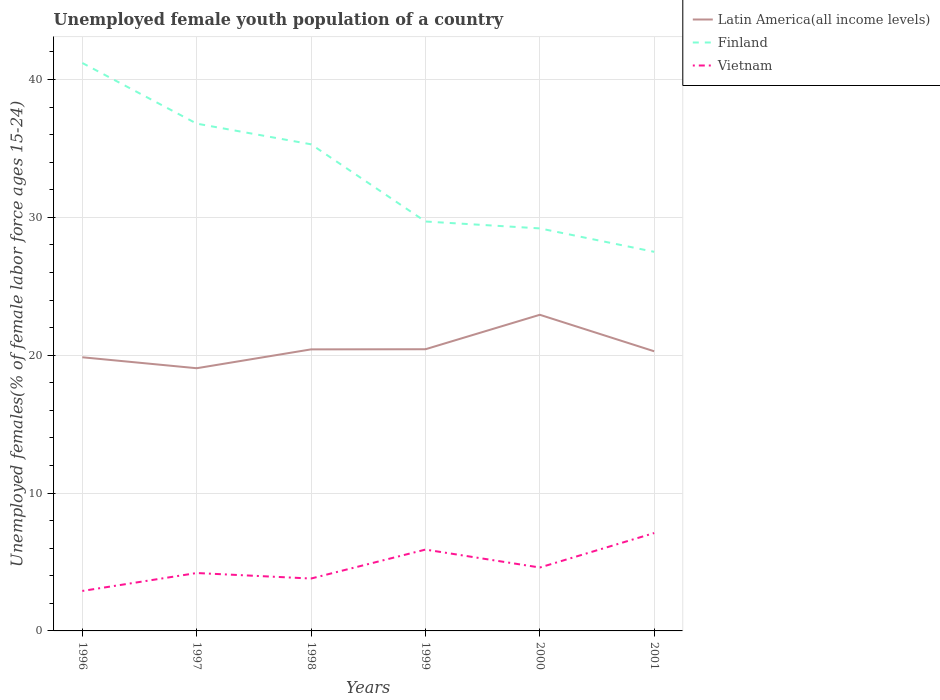How many different coloured lines are there?
Keep it short and to the point. 3. Across all years, what is the maximum percentage of unemployed female youth population in Finland?
Your answer should be very brief. 27.5. In which year was the percentage of unemployed female youth population in Latin America(all income levels) maximum?
Make the answer very short. 1997. What is the total percentage of unemployed female youth population in Vietnam in the graph?
Give a very brief answer. -1.2. What is the difference between the highest and the second highest percentage of unemployed female youth population in Finland?
Keep it short and to the point. 13.7. What is the difference between the highest and the lowest percentage of unemployed female youth population in Vietnam?
Your answer should be very brief. 2. How many years are there in the graph?
Offer a very short reply. 6. How are the legend labels stacked?
Give a very brief answer. Vertical. What is the title of the graph?
Ensure brevity in your answer.  Unemployed female youth population of a country. What is the label or title of the Y-axis?
Provide a short and direct response. Unemployed females(% of female labor force ages 15-24). What is the Unemployed females(% of female labor force ages 15-24) of Latin America(all income levels) in 1996?
Make the answer very short. 19.85. What is the Unemployed females(% of female labor force ages 15-24) of Finland in 1996?
Ensure brevity in your answer.  41.2. What is the Unemployed females(% of female labor force ages 15-24) of Vietnam in 1996?
Offer a very short reply. 2.9. What is the Unemployed females(% of female labor force ages 15-24) of Latin America(all income levels) in 1997?
Your answer should be very brief. 19.06. What is the Unemployed females(% of female labor force ages 15-24) in Finland in 1997?
Give a very brief answer. 36.8. What is the Unemployed females(% of female labor force ages 15-24) of Vietnam in 1997?
Provide a short and direct response. 4.2. What is the Unemployed females(% of female labor force ages 15-24) in Latin America(all income levels) in 1998?
Your answer should be very brief. 20.42. What is the Unemployed females(% of female labor force ages 15-24) of Finland in 1998?
Your answer should be very brief. 35.3. What is the Unemployed females(% of female labor force ages 15-24) of Vietnam in 1998?
Your response must be concise. 3.8. What is the Unemployed females(% of female labor force ages 15-24) of Latin America(all income levels) in 1999?
Offer a terse response. 20.43. What is the Unemployed females(% of female labor force ages 15-24) of Finland in 1999?
Provide a short and direct response. 29.7. What is the Unemployed females(% of female labor force ages 15-24) in Vietnam in 1999?
Provide a short and direct response. 5.9. What is the Unemployed females(% of female labor force ages 15-24) in Latin America(all income levels) in 2000?
Your response must be concise. 22.93. What is the Unemployed females(% of female labor force ages 15-24) of Finland in 2000?
Make the answer very short. 29.2. What is the Unemployed females(% of female labor force ages 15-24) in Vietnam in 2000?
Offer a very short reply. 4.6. What is the Unemployed females(% of female labor force ages 15-24) in Latin America(all income levels) in 2001?
Provide a short and direct response. 20.29. What is the Unemployed females(% of female labor force ages 15-24) in Finland in 2001?
Provide a succinct answer. 27.5. What is the Unemployed females(% of female labor force ages 15-24) in Vietnam in 2001?
Make the answer very short. 7.1. Across all years, what is the maximum Unemployed females(% of female labor force ages 15-24) in Latin America(all income levels)?
Your answer should be compact. 22.93. Across all years, what is the maximum Unemployed females(% of female labor force ages 15-24) of Finland?
Offer a very short reply. 41.2. Across all years, what is the maximum Unemployed females(% of female labor force ages 15-24) of Vietnam?
Your answer should be compact. 7.1. Across all years, what is the minimum Unemployed females(% of female labor force ages 15-24) of Latin America(all income levels)?
Make the answer very short. 19.06. Across all years, what is the minimum Unemployed females(% of female labor force ages 15-24) of Finland?
Keep it short and to the point. 27.5. Across all years, what is the minimum Unemployed females(% of female labor force ages 15-24) in Vietnam?
Your answer should be very brief. 2.9. What is the total Unemployed females(% of female labor force ages 15-24) of Latin America(all income levels) in the graph?
Your answer should be compact. 122.98. What is the total Unemployed females(% of female labor force ages 15-24) of Finland in the graph?
Give a very brief answer. 199.7. What is the difference between the Unemployed females(% of female labor force ages 15-24) of Latin America(all income levels) in 1996 and that in 1997?
Your response must be concise. 0.79. What is the difference between the Unemployed females(% of female labor force ages 15-24) of Finland in 1996 and that in 1997?
Offer a very short reply. 4.4. What is the difference between the Unemployed females(% of female labor force ages 15-24) of Vietnam in 1996 and that in 1997?
Provide a short and direct response. -1.3. What is the difference between the Unemployed females(% of female labor force ages 15-24) in Latin America(all income levels) in 1996 and that in 1998?
Your response must be concise. -0.57. What is the difference between the Unemployed females(% of female labor force ages 15-24) in Vietnam in 1996 and that in 1998?
Offer a very short reply. -0.9. What is the difference between the Unemployed females(% of female labor force ages 15-24) of Latin America(all income levels) in 1996 and that in 1999?
Your answer should be very brief. -0.58. What is the difference between the Unemployed females(% of female labor force ages 15-24) of Latin America(all income levels) in 1996 and that in 2000?
Make the answer very short. -3.08. What is the difference between the Unemployed females(% of female labor force ages 15-24) in Latin America(all income levels) in 1996 and that in 2001?
Make the answer very short. -0.44. What is the difference between the Unemployed females(% of female labor force ages 15-24) in Vietnam in 1996 and that in 2001?
Offer a terse response. -4.2. What is the difference between the Unemployed females(% of female labor force ages 15-24) of Latin America(all income levels) in 1997 and that in 1998?
Your response must be concise. -1.37. What is the difference between the Unemployed females(% of female labor force ages 15-24) of Finland in 1997 and that in 1998?
Provide a short and direct response. 1.5. What is the difference between the Unemployed females(% of female labor force ages 15-24) of Latin America(all income levels) in 1997 and that in 1999?
Provide a succinct answer. -1.38. What is the difference between the Unemployed females(% of female labor force ages 15-24) in Finland in 1997 and that in 1999?
Offer a terse response. 7.1. What is the difference between the Unemployed females(% of female labor force ages 15-24) of Latin America(all income levels) in 1997 and that in 2000?
Make the answer very short. -3.88. What is the difference between the Unemployed females(% of female labor force ages 15-24) of Vietnam in 1997 and that in 2000?
Provide a succinct answer. -0.4. What is the difference between the Unemployed females(% of female labor force ages 15-24) in Latin America(all income levels) in 1997 and that in 2001?
Offer a terse response. -1.23. What is the difference between the Unemployed females(% of female labor force ages 15-24) of Latin America(all income levels) in 1998 and that in 1999?
Offer a terse response. -0.01. What is the difference between the Unemployed females(% of female labor force ages 15-24) of Finland in 1998 and that in 1999?
Your response must be concise. 5.6. What is the difference between the Unemployed females(% of female labor force ages 15-24) in Latin America(all income levels) in 1998 and that in 2000?
Offer a very short reply. -2.51. What is the difference between the Unemployed females(% of female labor force ages 15-24) of Latin America(all income levels) in 1998 and that in 2001?
Offer a very short reply. 0.14. What is the difference between the Unemployed females(% of female labor force ages 15-24) in Finland in 1998 and that in 2001?
Your response must be concise. 7.8. What is the difference between the Unemployed females(% of female labor force ages 15-24) of Latin America(all income levels) in 1999 and that in 2000?
Your response must be concise. -2.5. What is the difference between the Unemployed females(% of female labor force ages 15-24) of Finland in 1999 and that in 2000?
Keep it short and to the point. 0.5. What is the difference between the Unemployed females(% of female labor force ages 15-24) of Vietnam in 1999 and that in 2000?
Keep it short and to the point. 1.3. What is the difference between the Unemployed females(% of female labor force ages 15-24) of Latin America(all income levels) in 1999 and that in 2001?
Ensure brevity in your answer.  0.15. What is the difference between the Unemployed females(% of female labor force ages 15-24) of Finland in 1999 and that in 2001?
Make the answer very short. 2.2. What is the difference between the Unemployed females(% of female labor force ages 15-24) in Latin America(all income levels) in 2000 and that in 2001?
Your response must be concise. 2.65. What is the difference between the Unemployed females(% of female labor force ages 15-24) in Finland in 2000 and that in 2001?
Offer a terse response. 1.7. What is the difference between the Unemployed females(% of female labor force ages 15-24) of Latin America(all income levels) in 1996 and the Unemployed females(% of female labor force ages 15-24) of Finland in 1997?
Provide a succinct answer. -16.95. What is the difference between the Unemployed females(% of female labor force ages 15-24) of Latin America(all income levels) in 1996 and the Unemployed females(% of female labor force ages 15-24) of Vietnam in 1997?
Offer a terse response. 15.65. What is the difference between the Unemployed females(% of female labor force ages 15-24) in Latin America(all income levels) in 1996 and the Unemployed females(% of female labor force ages 15-24) in Finland in 1998?
Offer a terse response. -15.45. What is the difference between the Unemployed females(% of female labor force ages 15-24) in Latin America(all income levels) in 1996 and the Unemployed females(% of female labor force ages 15-24) in Vietnam in 1998?
Ensure brevity in your answer.  16.05. What is the difference between the Unemployed females(% of female labor force ages 15-24) in Finland in 1996 and the Unemployed females(% of female labor force ages 15-24) in Vietnam in 1998?
Keep it short and to the point. 37.4. What is the difference between the Unemployed females(% of female labor force ages 15-24) in Latin America(all income levels) in 1996 and the Unemployed females(% of female labor force ages 15-24) in Finland in 1999?
Give a very brief answer. -9.85. What is the difference between the Unemployed females(% of female labor force ages 15-24) of Latin America(all income levels) in 1996 and the Unemployed females(% of female labor force ages 15-24) of Vietnam in 1999?
Your answer should be compact. 13.95. What is the difference between the Unemployed females(% of female labor force ages 15-24) of Finland in 1996 and the Unemployed females(% of female labor force ages 15-24) of Vietnam in 1999?
Offer a terse response. 35.3. What is the difference between the Unemployed females(% of female labor force ages 15-24) of Latin America(all income levels) in 1996 and the Unemployed females(% of female labor force ages 15-24) of Finland in 2000?
Offer a terse response. -9.35. What is the difference between the Unemployed females(% of female labor force ages 15-24) of Latin America(all income levels) in 1996 and the Unemployed females(% of female labor force ages 15-24) of Vietnam in 2000?
Keep it short and to the point. 15.25. What is the difference between the Unemployed females(% of female labor force ages 15-24) in Finland in 1996 and the Unemployed females(% of female labor force ages 15-24) in Vietnam in 2000?
Keep it short and to the point. 36.6. What is the difference between the Unemployed females(% of female labor force ages 15-24) in Latin America(all income levels) in 1996 and the Unemployed females(% of female labor force ages 15-24) in Finland in 2001?
Keep it short and to the point. -7.65. What is the difference between the Unemployed females(% of female labor force ages 15-24) in Latin America(all income levels) in 1996 and the Unemployed females(% of female labor force ages 15-24) in Vietnam in 2001?
Provide a succinct answer. 12.75. What is the difference between the Unemployed females(% of female labor force ages 15-24) of Finland in 1996 and the Unemployed females(% of female labor force ages 15-24) of Vietnam in 2001?
Provide a short and direct response. 34.1. What is the difference between the Unemployed females(% of female labor force ages 15-24) in Latin America(all income levels) in 1997 and the Unemployed females(% of female labor force ages 15-24) in Finland in 1998?
Ensure brevity in your answer.  -16.24. What is the difference between the Unemployed females(% of female labor force ages 15-24) of Latin America(all income levels) in 1997 and the Unemployed females(% of female labor force ages 15-24) of Vietnam in 1998?
Give a very brief answer. 15.26. What is the difference between the Unemployed females(% of female labor force ages 15-24) of Finland in 1997 and the Unemployed females(% of female labor force ages 15-24) of Vietnam in 1998?
Make the answer very short. 33. What is the difference between the Unemployed females(% of female labor force ages 15-24) in Latin America(all income levels) in 1997 and the Unemployed females(% of female labor force ages 15-24) in Finland in 1999?
Provide a succinct answer. -10.64. What is the difference between the Unemployed females(% of female labor force ages 15-24) in Latin America(all income levels) in 1997 and the Unemployed females(% of female labor force ages 15-24) in Vietnam in 1999?
Your answer should be compact. 13.16. What is the difference between the Unemployed females(% of female labor force ages 15-24) of Finland in 1997 and the Unemployed females(% of female labor force ages 15-24) of Vietnam in 1999?
Ensure brevity in your answer.  30.9. What is the difference between the Unemployed females(% of female labor force ages 15-24) of Latin America(all income levels) in 1997 and the Unemployed females(% of female labor force ages 15-24) of Finland in 2000?
Give a very brief answer. -10.14. What is the difference between the Unemployed females(% of female labor force ages 15-24) of Latin America(all income levels) in 1997 and the Unemployed females(% of female labor force ages 15-24) of Vietnam in 2000?
Your answer should be very brief. 14.46. What is the difference between the Unemployed females(% of female labor force ages 15-24) of Finland in 1997 and the Unemployed females(% of female labor force ages 15-24) of Vietnam in 2000?
Your answer should be compact. 32.2. What is the difference between the Unemployed females(% of female labor force ages 15-24) in Latin America(all income levels) in 1997 and the Unemployed females(% of female labor force ages 15-24) in Finland in 2001?
Keep it short and to the point. -8.44. What is the difference between the Unemployed females(% of female labor force ages 15-24) in Latin America(all income levels) in 1997 and the Unemployed females(% of female labor force ages 15-24) in Vietnam in 2001?
Your answer should be very brief. 11.96. What is the difference between the Unemployed females(% of female labor force ages 15-24) in Finland in 1997 and the Unemployed females(% of female labor force ages 15-24) in Vietnam in 2001?
Provide a succinct answer. 29.7. What is the difference between the Unemployed females(% of female labor force ages 15-24) in Latin America(all income levels) in 1998 and the Unemployed females(% of female labor force ages 15-24) in Finland in 1999?
Offer a very short reply. -9.28. What is the difference between the Unemployed females(% of female labor force ages 15-24) of Latin America(all income levels) in 1998 and the Unemployed females(% of female labor force ages 15-24) of Vietnam in 1999?
Provide a succinct answer. 14.52. What is the difference between the Unemployed females(% of female labor force ages 15-24) of Finland in 1998 and the Unemployed females(% of female labor force ages 15-24) of Vietnam in 1999?
Offer a terse response. 29.4. What is the difference between the Unemployed females(% of female labor force ages 15-24) in Latin America(all income levels) in 1998 and the Unemployed females(% of female labor force ages 15-24) in Finland in 2000?
Provide a succinct answer. -8.78. What is the difference between the Unemployed females(% of female labor force ages 15-24) in Latin America(all income levels) in 1998 and the Unemployed females(% of female labor force ages 15-24) in Vietnam in 2000?
Provide a succinct answer. 15.82. What is the difference between the Unemployed females(% of female labor force ages 15-24) of Finland in 1998 and the Unemployed females(% of female labor force ages 15-24) of Vietnam in 2000?
Offer a terse response. 30.7. What is the difference between the Unemployed females(% of female labor force ages 15-24) in Latin America(all income levels) in 1998 and the Unemployed females(% of female labor force ages 15-24) in Finland in 2001?
Provide a short and direct response. -7.08. What is the difference between the Unemployed females(% of female labor force ages 15-24) in Latin America(all income levels) in 1998 and the Unemployed females(% of female labor force ages 15-24) in Vietnam in 2001?
Your response must be concise. 13.32. What is the difference between the Unemployed females(% of female labor force ages 15-24) in Finland in 1998 and the Unemployed females(% of female labor force ages 15-24) in Vietnam in 2001?
Your answer should be compact. 28.2. What is the difference between the Unemployed females(% of female labor force ages 15-24) in Latin America(all income levels) in 1999 and the Unemployed females(% of female labor force ages 15-24) in Finland in 2000?
Ensure brevity in your answer.  -8.77. What is the difference between the Unemployed females(% of female labor force ages 15-24) of Latin America(all income levels) in 1999 and the Unemployed females(% of female labor force ages 15-24) of Vietnam in 2000?
Keep it short and to the point. 15.83. What is the difference between the Unemployed females(% of female labor force ages 15-24) in Finland in 1999 and the Unemployed females(% of female labor force ages 15-24) in Vietnam in 2000?
Make the answer very short. 25.1. What is the difference between the Unemployed females(% of female labor force ages 15-24) in Latin America(all income levels) in 1999 and the Unemployed females(% of female labor force ages 15-24) in Finland in 2001?
Your response must be concise. -7.07. What is the difference between the Unemployed females(% of female labor force ages 15-24) of Latin America(all income levels) in 1999 and the Unemployed females(% of female labor force ages 15-24) of Vietnam in 2001?
Ensure brevity in your answer.  13.33. What is the difference between the Unemployed females(% of female labor force ages 15-24) of Finland in 1999 and the Unemployed females(% of female labor force ages 15-24) of Vietnam in 2001?
Your answer should be compact. 22.6. What is the difference between the Unemployed females(% of female labor force ages 15-24) in Latin America(all income levels) in 2000 and the Unemployed females(% of female labor force ages 15-24) in Finland in 2001?
Give a very brief answer. -4.57. What is the difference between the Unemployed females(% of female labor force ages 15-24) in Latin America(all income levels) in 2000 and the Unemployed females(% of female labor force ages 15-24) in Vietnam in 2001?
Make the answer very short. 15.83. What is the difference between the Unemployed females(% of female labor force ages 15-24) in Finland in 2000 and the Unemployed females(% of female labor force ages 15-24) in Vietnam in 2001?
Your response must be concise. 22.1. What is the average Unemployed females(% of female labor force ages 15-24) of Latin America(all income levels) per year?
Your response must be concise. 20.5. What is the average Unemployed females(% of female labor force ages 15-24) of Finland per year?
Your answer should be compact. 33.28. What is the average Unemployed females(% of female labor force ages 15-24) in Vietnam per year?
Give a very brief answer. 4.75. In the year 1996, what is the difference between the Unemployed females(% of female labor force ages 15-24) of Latin America(all income levels) and Unemployed females(% of female labor force ages 15-24) of Finland?
Provide a succinct answer. -21.35. In the year 1996, what is the difference between the Unemployed females(% of female labor force ages 15-24) of Latin America(all income levels) and Unemployed females(% of female labor force ages 15-24) of Vietnam?
Offer a terse response. 16.95. In the year 1996, what is the difference between the Unemployed females(% of female labor force ages 15-24) of Finland and Unemployed females(% of female labor force ages 15-24) of Vietnam?
Offer a terse response. 38.3. In the year 1997, what is the difference between the Unemployed females(% of female labor force ages 15-24) in Latin America(all income levels) and Unemployed females(% of female labor force ages 15-24) in Finland?
Ensure brevity in your answer.  -17.74. In the year 1997, what is the difference between the Unemployed females(% of female labor force ages 15-24) of Latin America(all income levels) and Unemployed females(% of female labor force ages 15-24) of Vietnam?
Ensure brevity in your answer.  14.86. In the year 1997, what is the difference between the Unemployed females(% of female labor force ages 15-24) in Finland and Unemployed females(% of female labor force ages 15-24) in Vietnam?
Make the answer very short. 32.6. In the year 1998, what is the difference between the Unemployed females(% of female labor force ages 15-24) in Latin America(all income levels) and Unemployed females(% of female labor force ages 15-24) in Finland?
Your answer should be compact. -14.88. In the year 1998, what is the difference between the Unemployed females(% of female labor force ages 15-24) of Latin America(all income levels) and Unemployed females(% of female labor force ages 15-24) of Vietnam?
Keep it short and to the point. 16.62. In the year 1998, what is the difference between the Unemployed females(% of female labor force ages 15-24) in Finland and Unemployed females(% of female labor force ages 15-24) in Vietnam?
Offer a very short reply. 31.5. In the year 1999, what is the difference between the Unemployed females(% of female labor force ages 15-24) of Latin America(all income levels) and Unemployed females(% of female labor force ages 15-24) of Finland?
Offer a very short reply. -9.27. In the year 1999, what is the difference between the Unemployed females(% of female labor force ages 15-24) of Latin America(all income levels) and Unemployed females(% of female labor force ages 15-24) of Vietnam?
Make the answer very short. 14.53. In the year 1999, what is the difference between the Unemployed females(% of female labor force ages 15-24) of Finland and Unemployed females(% of female labor force ages 15-24) of Vietnam?
Ensure brevity in your answer.  23.8. In the year 2000, what is the difference between the Unemployed females(% of female labor force ages 15-24) of Latin America(all income levels) and Unemployed females(% of female labor force ages 15-24) of Finland?
Offer a very short reply. -6.27. In the year 2000, what is the difference between the Unemployed females(% of female labor force ages 15-24) of Latin America(all income levels) and Unemployed females(% of female labor force ages 15-24) of Vietnam?
Offer a very short reply. 18.33. In the year 2000, what is the difference between the Unemployed females(% of female labor force ages 15-24) of Finland and Unemployed females(% of female labor force ages 15-24) of Vietnam?
Make the answer very short. 24.6. In the year 2001, what is the difference between the Unemployed females(% of female labor force ages 15-24) in Latin America(all income levels) and Unemployed females(% of female labor force ages 15-24) in Finland?
Give a very brief answer. -7.21. In the year 2001, what is the difference between the Unemployed females(% of female labor force ages 15-24) of Latin America(all income levels) and Unemployed females(% of female labor force ages 15-24) of Vietnam?
Give a very brief answer. 13.19. In the year 2001, what is the difference between the Unemployed females(% of female labor force ages 15-24) in Finland and Unemployed females(% of female labor force ages 15-24) in Vietnam?
Your answer should be very brief. 20.4. What is the ratio of the Unemployed females(% of female labor force ages 15-24) of Latin America(all income levels) in 1996 to that in 1997?
Offer a terse response. 1.04. What is the ratio of the Unemployed females(% of female labor force ages 15-24) of Finland in 1996 to that in 1997?
Offer a very short reply. 1.12. What is the ratio of the Unemployed females(% of female labor force ages 15-24) in Vietnam in 1996 to that in 1997?
Ensure brevity in your answer.  0.69. What is the ratio of the Unemployed females(% of female labor force ages 15-24) in Latin America(all income levels) in 1996 to that in 1998?
Provide a short and direct response. 0.97. What is the ratio of the Unemployed females(% of female labor force ages 15-24) of Finland in 1996 to that in 1998?
Offer a very short reply. 1.17. What is the ratio of the Unemployed females(% of female labor force ages 15-24) of Vietnam in 1996 to that in 1998?
Provide a succinct answer. 0.76. What is the ratio of the Unemployed females(% of female labor force ages 15-24) in Latin America(all income levels) in 1996 to that in 1999?
Your answer should be compact. 0.97. What is the ratio of the Unemployed females(% of female labor force ages 15-24) in Finland in 1996 to that in 1999?
Your answer should be very brief. 1.39. What is the ratio of the Unemployed females(% of female labor force ages 15-24) in Vietnam in 1996 to that in 1999?
Your response must be concise. 0.49. What is the ratio of the Unemployed females(% of female labor force ages 15-24) of Latin America(all income levels) in 1996 to that in 2000?
Offer a terse response. 0.87. What is the ratio of the Unemployed females(% of female labor force ages 15-24) of Finland in 1996 to that in 2000?
Offer a terse response. 1.41. What is the ratio of the Unemployed females(% of female labor force ages 15-24) of Vietnam in 1996 to that in 2000?
Offer a terse response. 0.63. What is the ratio of the Unemployed females(% of female labor force ages 15-24) of Latin America(all income levels) in 1996 to that in 2001?
Offer a terse response. 0.98. What is the ratio of the Unemployed females(% of female labor force ages 15-24) in Finland in 1996 to that in 2001?
Your response must be concise. 1.5. What is the ratio of the Unemployed females(% of female labor force ages 15-24) of Vietnam in 1996 to that in 2001?
Offer a very short reply. 0.41. What is the ratio of the Unemployed females(% of female labor force ages 15-24) in Latin America(all income levels) in 1997 to that in 1998?
Keep it short and to the point. 0.93. What is the ratio of the Unemployed females(% of female labor force ages 15-24) of Finland in 1997 to that in 1998?
Offer a very short reply. 1.04. What is the ratio of the Unemployed females(% of female labor force ages 15-24) in Vietnam in 1997 to that in 1998?
Your answer should be very brief. 1.11. What is the ratio of the Unemployed females(% of female labor force ages 15-24) of Latin America(all income levels) in 1997 to that in 1999?
Ensure brevity in your answer.  0.93. What is the ratio of the Unemployed females(% of female labor force ages 15-24) of Finland in 1997 to that in 1999?
Provide a succinct answer. 1.24. What is the ratio of the Unemployed females(% of female labor force ages 15-24) of Vietnam in 1997 to that in 1999?
Your response must be concise. 0.71. What is the ratio of the Unemployed females(% of female labor force ages 15-24) of Latin America(all income levels) in 1997 to that in 2000?
Your response must be concise. 0.83. What is the ratio of the Unemployed females(% of female labor force ages 15-24) of Finland in 1997 to that in 2000?
Offer a terse response. 1.26. What is the ratio of the Unemployed females(% of female labor force ages 15-24) of Latin America(all income levels) in 1997 to that in 2001?
Provide a short and direct response. 0.94. What is the ratio of the Unemployed females(% of female labor force ages 15-24) of Finland in 1997 to that in 2001?
Make the answer very short. 1.34. What is the ratio of the Unemployed females(% of female labor force ages 15-24) of Vietnam in 1997 to that in 2001?
Provide a succinct answer. 0.59. What is the ratio of the Unemployed females(% of female labor force ages 15-24) in Finland in 1998 to that in 1999?
Your answer should be very brief. 1.19. What is the ratio of the Unemployed females(% of female labor force ages 15-24) of Vietnam in 1998 to that in 1999?
Your response must be concise. 0.64. What is the ratio of the Unemployed females(% of female labor force ages 15-24) in Latin America(all income levels) in 1998 to that in 2000?
Keep it short and to the point. 0.89. What is the ratio of the Unemployed females(% of female labor force ages 15-24) in Finland in 1998 to that in 2000?
Make the answer very short. 1.21. What is the ratio of the Unemployed females(% of female labor force ages 15-24) of Vietnam in 1998 to that in 2000?
Offer a terse response. 0.83. What is the ratio of the Unemployed females(% of female labor force ages 15-24) of Latin America(all income levels) in 1998 to that in 2001?
Offer a terse response. 1.01. What is the ratio of the Unemployed females(% of female labor force ages 15-24) in Finland in 1998 to that in 2001?
Give a very brief answer. 1.28. What is the ratio of the Unemployed females(% of female labor force ages 15-24) of Vietnam in 1998 to that in 2001?
Your answer should be very brief. 0.54. What is the ratio of the Unemployed females(% of female labor force ages 15-24) of Latin America(all income levels) in 1999 to that in 2000?
Offer a very short reply. 0.89. What is the ratio of the Unemployed females(% of female labor force ages 15-24) of Finland in 1999 to that in 2000?
Give a very brief answer. 1.02. What is the ratio of the Unemployed females(% of female labor force ages 15-24) of Vietnam in 1999 to that in 2000?
Provide a succinct answer. 1.28. What is the ratio of the Unemployed females(% of female labor force ages 15-24) of Latin America(all income levels) in 1999 to that in 2001?
Make the answer very short. 1.01. What is the ratio of the Unemployed females(% of female labor force ages 15-24) of Vietnam in 1999 to that in 2001?
Your answer should be compact. 0.83. What is the ratio of the Unemployed females(% of female labor force ages 15-24) of Latin America(all income levels) in 2000 to that in 2001?
Provide a succinct answer. 1.13. What is the ratio of the Unemployed females(% of female labor force ages 15-24) in Finland in 2000 to that in 2001?
Offer a terse response. 1.06. What is the ratio of the Unemployed females(% of female labor force ages 15-24) in Vietnam in 2000 to that in 2001?
Your answer should be compact. 0.65. What is the difference between the highest and the second highest Unemployed females(% of female labor force ages 15-24) of Latin America(all income levels)?
Offer a terse response. 2.5. What is the difference between the highest and the second highest Unemployed females(% of female labor force ages 15-24) in Vietnam?
Your answer should be very brief. 1.2. What is the difference between the highest and the lowest Unemployed females(% of female labor force ages 15-24) of Latin America(all income levels)?
Offer a terse response. 3.88. What is the difference between the highest and the lowest Unemployed females(% of female labor force ages 15-24) of Vietnam?
Your response must be concise. 4.2. 